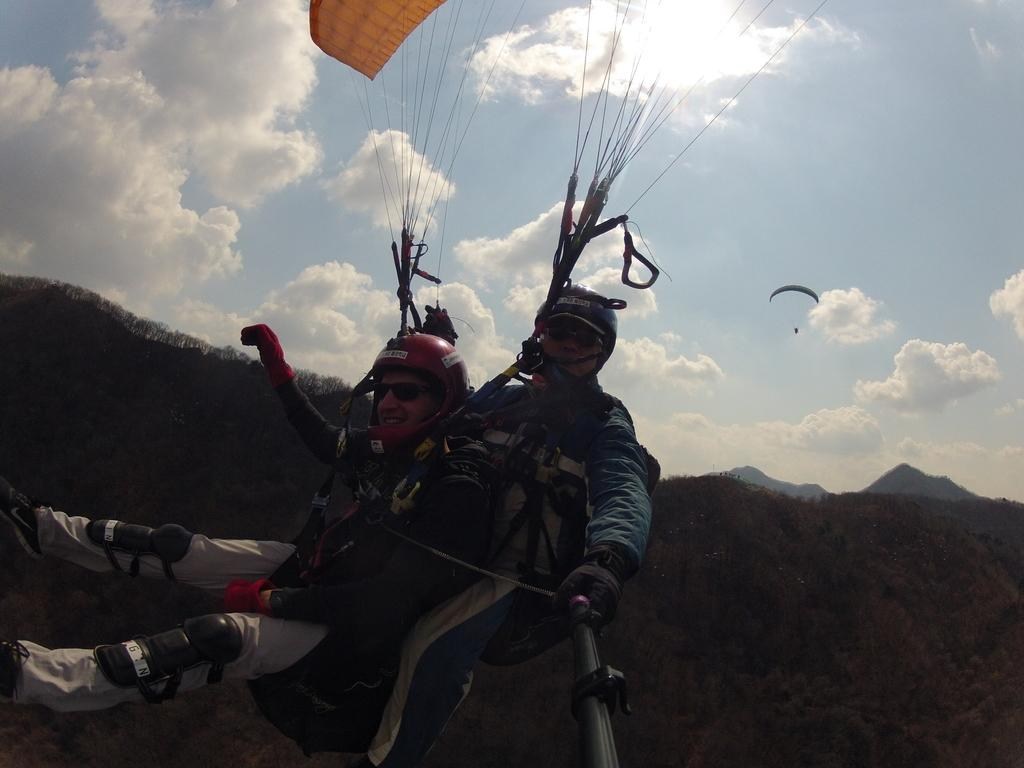What activity are the people in the image engaged in? The people in the image are skydiving. Can you describe what one person is holding while skydiving? One person is holding an object while skydiving. What type of landscape can be seen in the image? Hills are visible in the image. What is visible in the sky in the image? The sky is visible in the image, and clouds are present. What type of furniture can be seen in the image? There is no furniture present in the image; it features people skydiving over a landscape with hills and clouds. Can you recite a verse that is written on the clouds in the image? There is no verse written on the clouds in the image; the clouds are simply a natural part of the sky. 